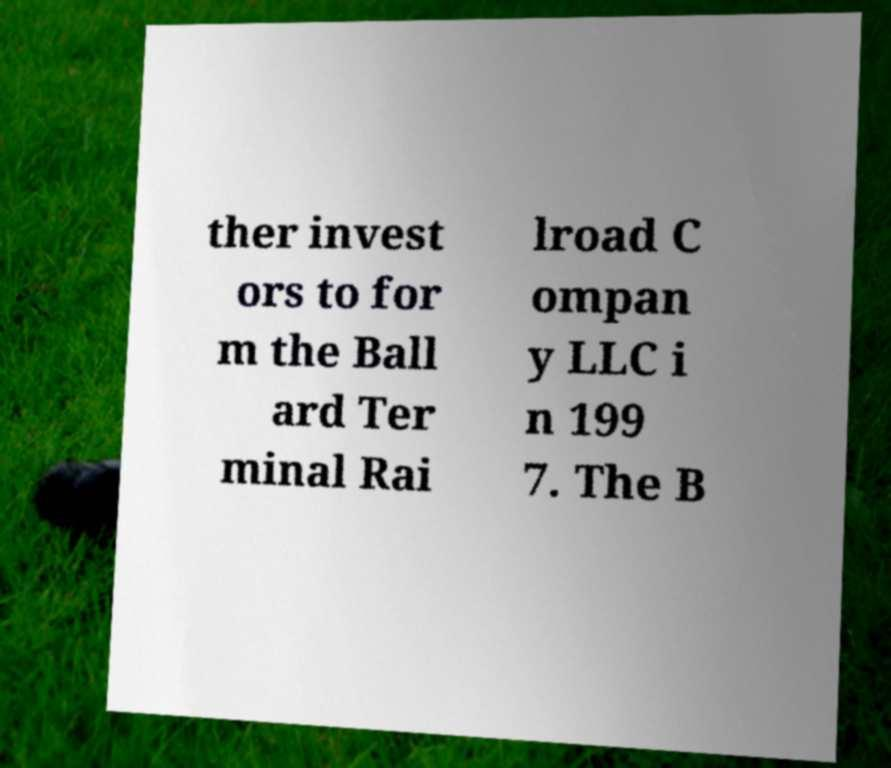Can you read and provide the text displayed in the image?This photo seems to have some interesting text. Can you extract and type it out for me? ther invest ors to for m the Ball ard Ter minal Rai lroad C ompan y LLC i n 199 7. The B 